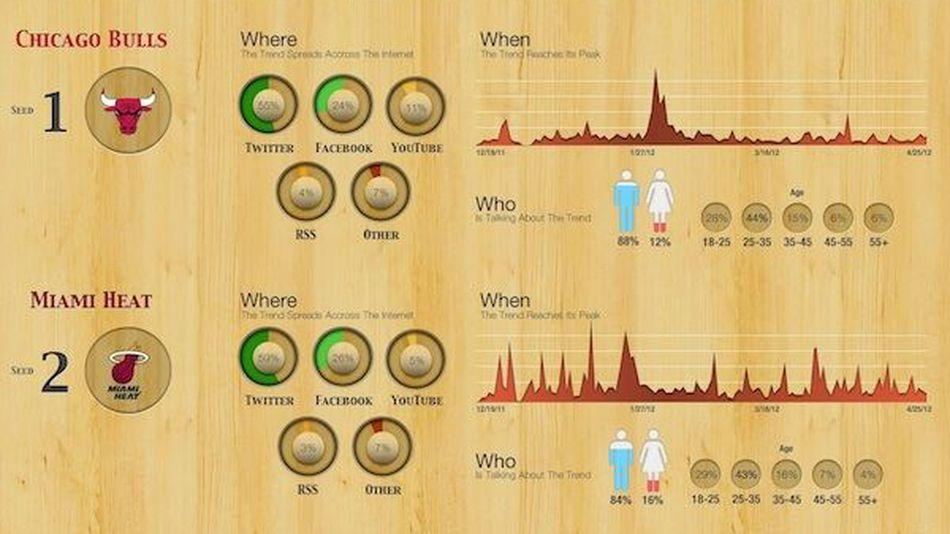Mention a couple of crucial points in this snapshot. The Chicago Bulls are more commonly discussed among males. It is more commonly discussed among females that the Miami Heat is the trend. Chicago Bulls are more active on YouTube than [insert comparison team]. According to recent research, 12% of females are discussing the Chicago Bulls. 